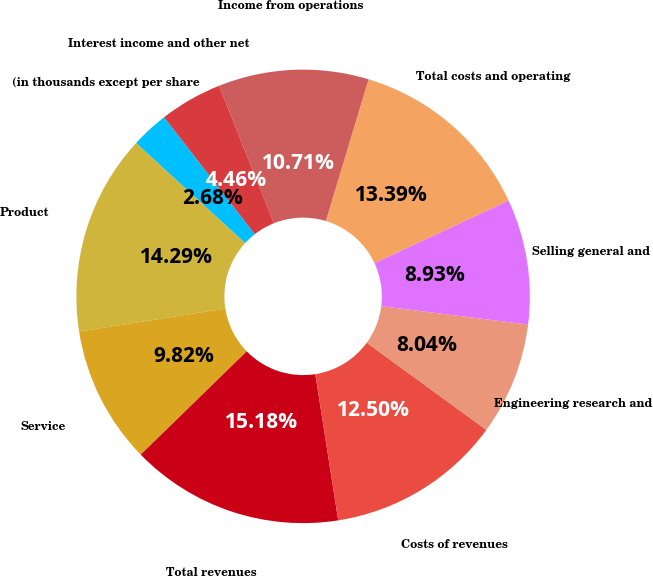<chart> <loc_0><loc_0><loc_500><loc_500><pie_chart><fcel>(in thousands except per share<fcel>Product<fcel>Service<fcel>Total revenues<fcel>Costs of revenues<fcel>Engineering research and<fcel>Selling general and<fcel>Total costs and operating<fcel>Income from operations<fcel>Interest income and other net<nl><fcel>2.68%<fcel>14.29%<fcel>9.82%<fcel>15.18%<fcel>12.5%<fcel>8.04%<fcel>8.93%<fcel>13.39%<fcel>10.71%<fcel>4.46%<nl></chart> 